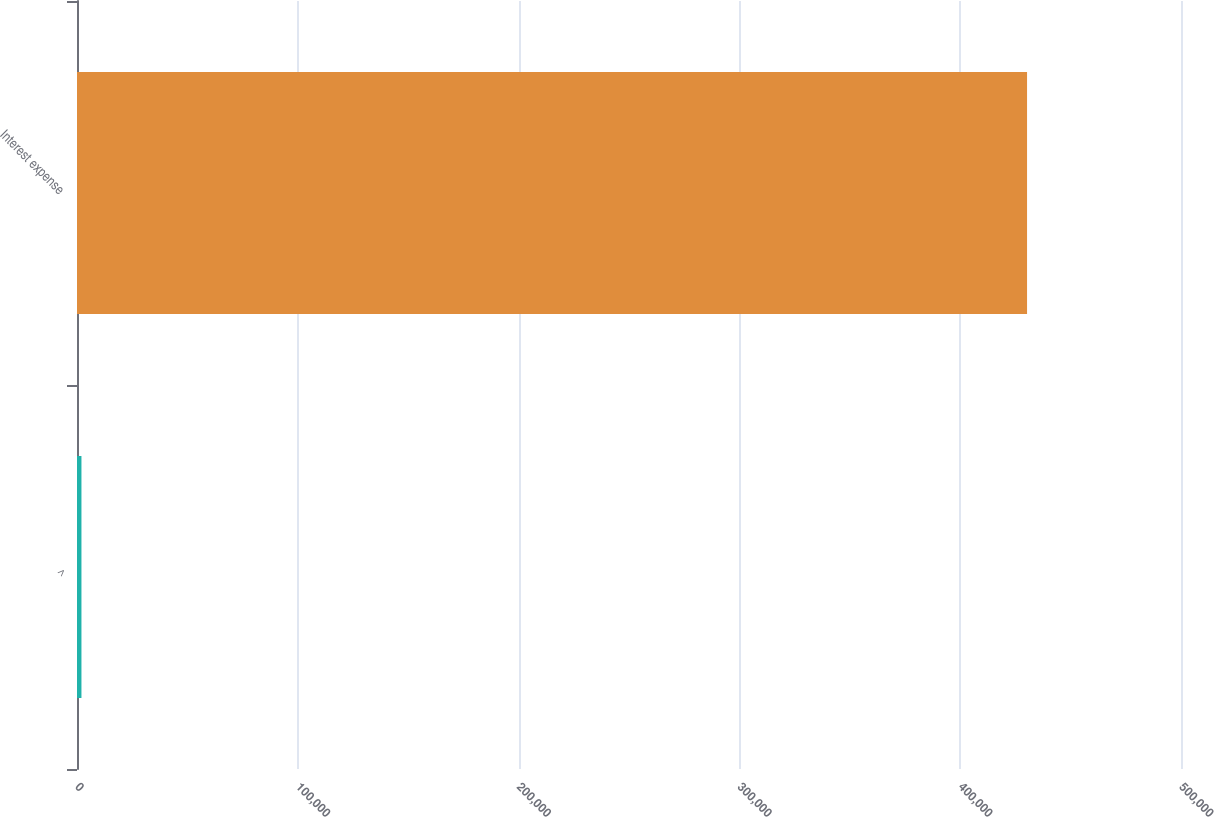Convert chart to OTSL. <chart><loc_0><loc_0><loc_500><loc_500><bar_chart><fcel>^<fcel>Interest expense<nl><fcel>2014<fcel>430278<nl></chart> 